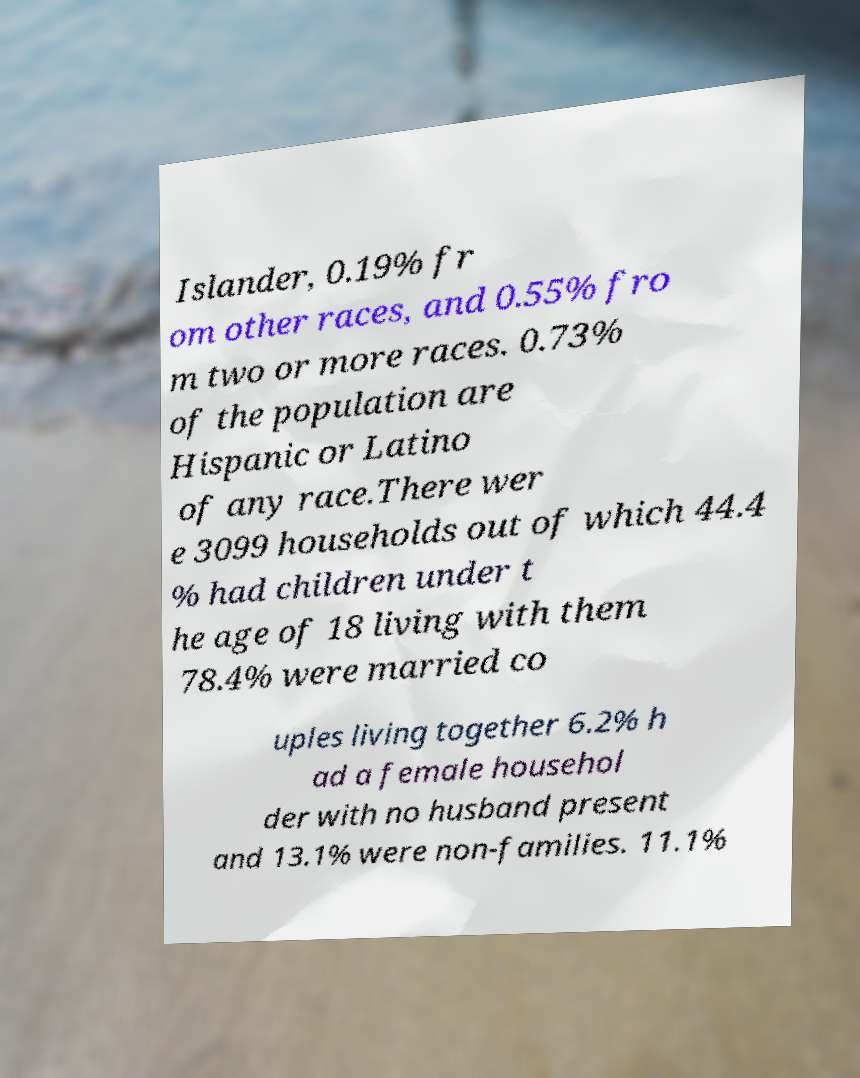Please read and relay the text visible in this image. What does it say? Islander, 0.19% fr om other races, and 0.55% fro m two or more races. 0.73% of the population are Hispanic or Latino of any race.There wer e 3099 households out of which 44.4 % had children under t he age of 18 living with them 78.4% were married co uples living together 6.2% h ad a female househol der with no husband present and 13.1% were non-families. 11.1% 